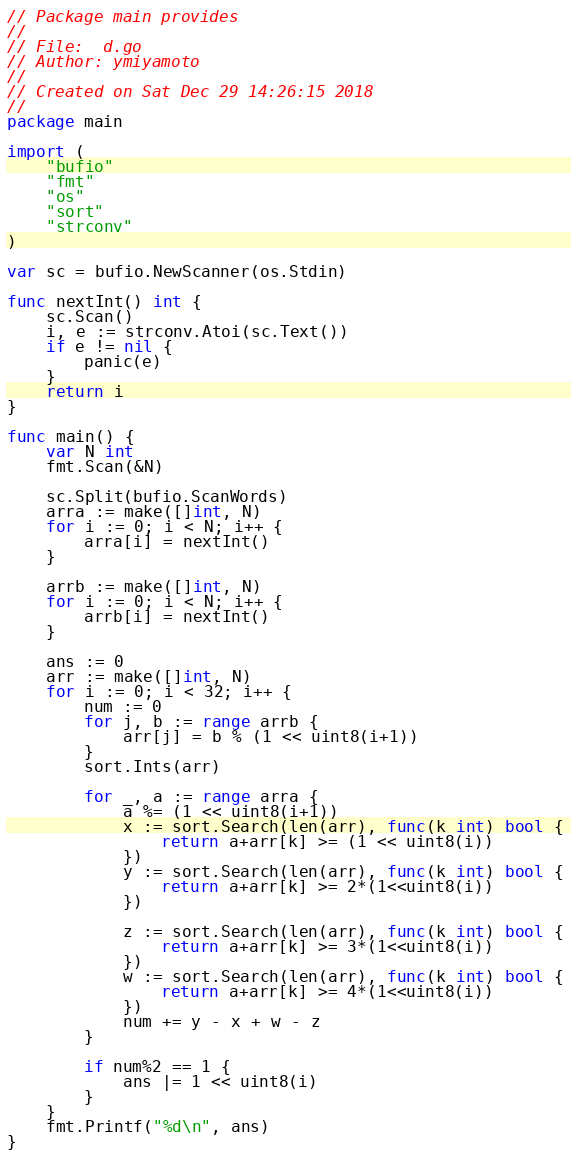<code> <loc_0><loc_0><loc_500><loc_500><_Go_>// Package main provides
//
// File:  d.go
// Author: ymiyamoto
//
// Created on Sat Dec 29 14:26:15 2018
//
package main

import (
	"bufio"
	"fmt"
	"os"
	"sort"
	"strconv"
)

var sc = bufio.NewScanner(os.Stdin)

func nextInt() int {
	sc.Scan()
	i, e := strconv.Atoi(sc.Text())
	if e != nil {
		panic(e)
	}
	return i
}

func main() {
	var N int
	fmt.Scan(&N)

	sc.Split(bufio.ScanWords)
	arra := make([]int, N)
	for i := 0; i < N; i++ {
		arra[i] = nextInt()
	}

	arrb := make([]int, N)
	for i := 0; i < N; i++ {
		arrb[i] = nextInt()
	}

	ans := 0
	arr := make([]int, N)
	for i := 0; i < 32; i++ {
		num := 0
		for j, b := range arrb {
			arr[j] = b % (1 << uint8(i+1))
		}
		sort.Ints(arr)

		for _, a := range arra {
			a %= (1 << uint8(i+1))
			x := sort.Search(len(arr), func(k int) bool {
				return a+arr[k] >= (1 << uint8(i))
			})
			y := sort.Search(len(arr), func(k int) bool {
				return a+arr[k] >= 2*(1<<uint8(i))
			})

			z := sort.Search(len(arr), func(k int) bool {
				return a+arr[k] >= 3*(1<<uint8(i))
			})
			w := sort.Search(len(arr), func(k int) bool {
				return a+arr[k] >= 4*(1<<uint8(i))
			})
			num += y - x + w - z
		}

		if num%2 == 1 {
			ans |= 1 << uint8(i)
		}
	}
	fmt.Printf("%d\n", ans)
}
</code> 